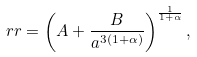Convert formula to latex. <formula><loc_0><loc_0><loc_500><loc_500>\ r r = \left ( A + \frac { B } { a ^ { 3 ( 1 + \alpha ) } } \right ) ^ { \frac { 1 } { 1 + \alpha } } ,</formula> 